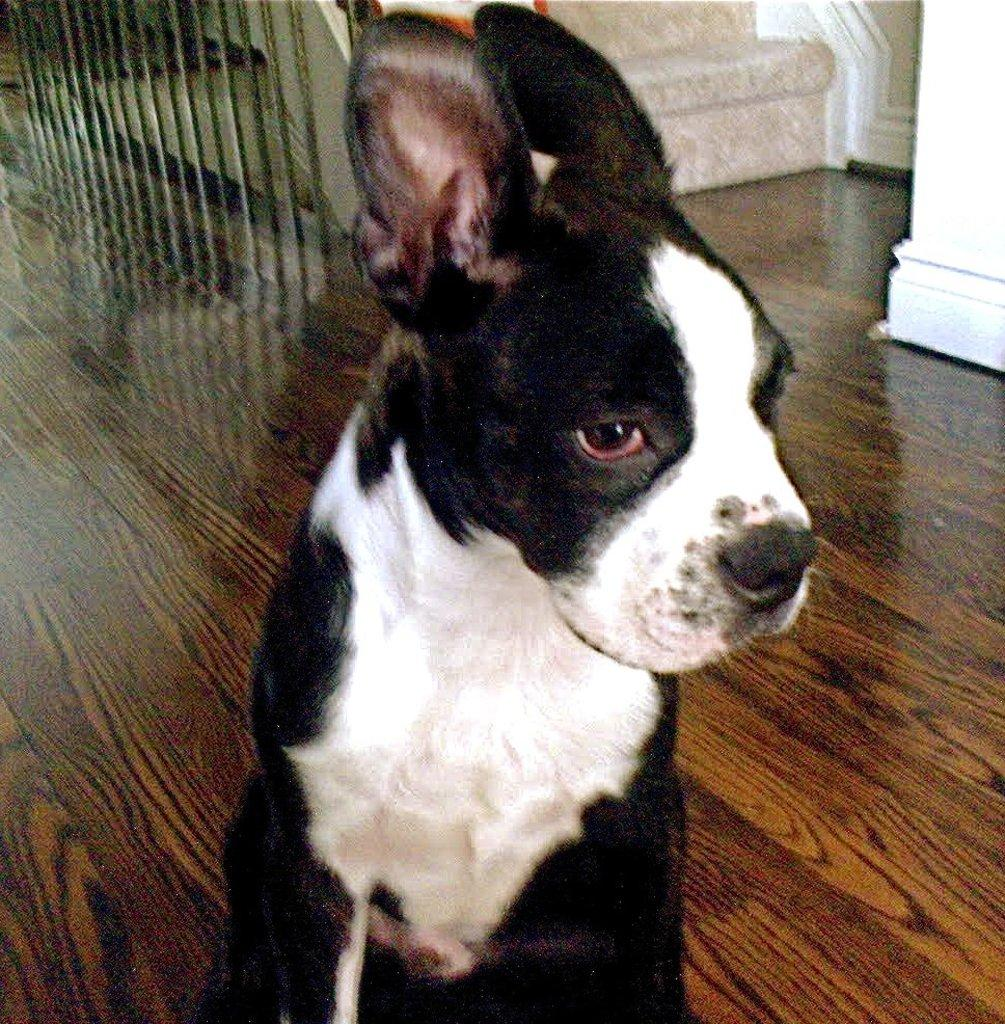What animal is on the floor in the image? There is a dog on the floor in the image. What architectural feature can be seen in the background of the image? There are steps in the background of the image. What is beside the steps? There is a railing beside the steps. What can be seen on the right side top of the image? There appears to be a pillar on the right side top of the image. What type of feast is being prepared in the image? There is no indication of a feast or any food preparation in the image. Can you describe the person holding the quince in the image? There is no person or quince present in the image. 